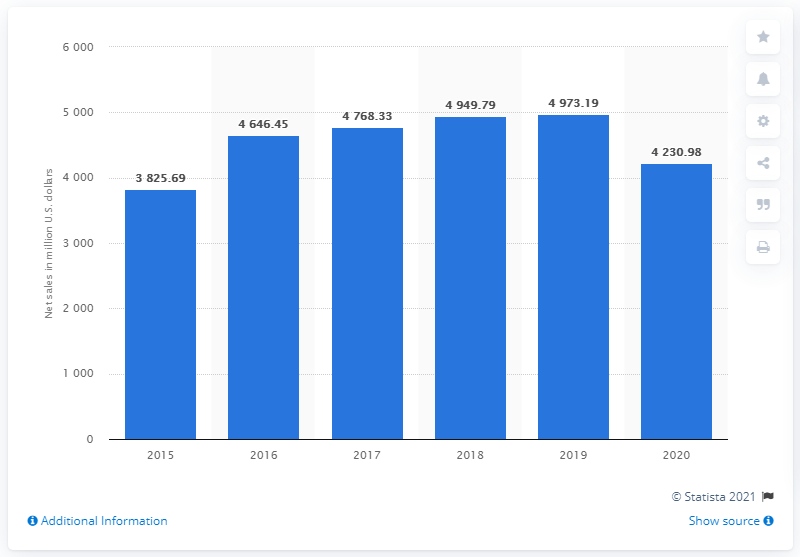Indicate a few pertinent items in this graphic. Under Armour's net sales worldwide in 2020 were 4230.98. 